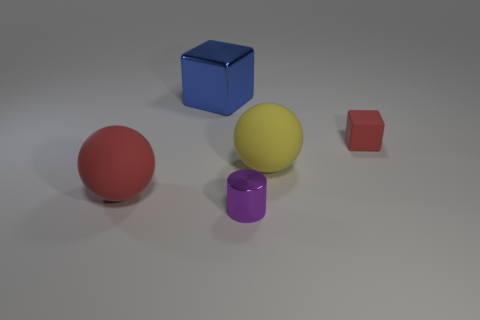Add 3 large cyan things. How many objects exist? 8 Subtract all spheres. How many objects are left? 3 Subtract 0 green cylinders. How many objects are left? 5 Subtract all big yellow rubber cylinders. Subtract all large red rubber things. How many objects are left? 4 Add 4 small purple cylinders. How many small purple cylinders are left? 5 Add 2 yellow matte objects. How many yellow matte objects exist? 3 